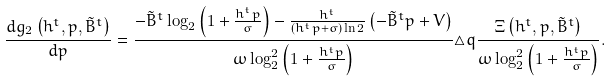<formula> <loc_0><loc_0><loc_500><loc_500>\frac { d g _ { 2 } \left ( h ^ { t } , p , \tilde { B } ^ { t } \right ) } { d p } = \frac { - \tilde { B } ^ { t } \log _ { 2 } \left ( 1 + \frac { h ^ { t } p } { \sigma } \right ) - \frac { h ^ { t } } { \left ( h ^ { t } p + \sigma \right ) \ln 2 } \left ( - \tilde { B } ^ { t } p + V \right ) } { \omega \log _ { 2 } ^ { 2 } \left ( 1 + \frac { h ^ { t } p } { \sigma } \right ) } \triangle q \frac { \Xi \left ( h ^ { t } , p , \tilde { B } ^ { t } \right ) } { \omega \log _ { 2 } ^ { 2 } \left ( 1 + \frac { h ^ { t } p } { \sigma } \right ) } .</formula> 